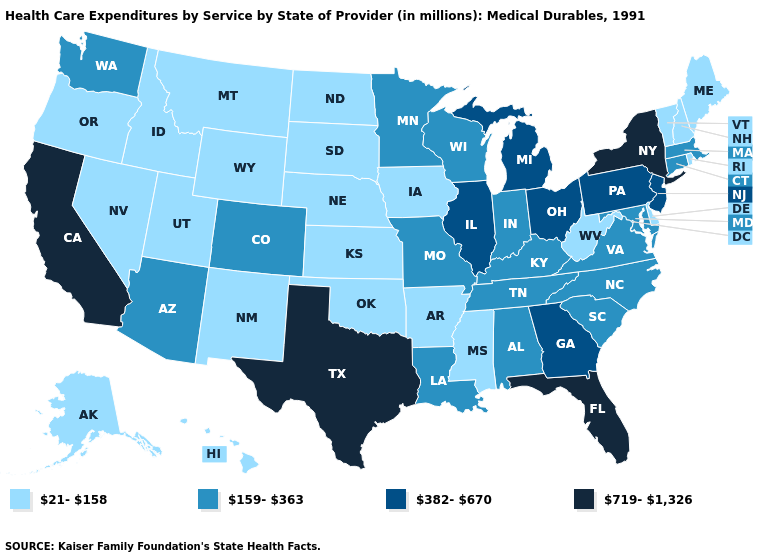What is the value of Alaska?
Write a very short answer. 21-158. Which states have the highest value in the USA?
Quick response, please. California, Florida, New York, Texas. Name the states that have a value in the range 159-363?
Keep it brief. Alabama, Arizona, Colorado, Connecticut, Indiana, Kentucky, Louisiana, Maryland, Massachusetts, Minnesota, Missouri, North Carolina, South Carolina, Tennessee, Virginia, Washington, Wisconsin. What is the value of South Carolina?
Be succinct. 159-363. What is the value of Louisiana?
Give a very brief answer. 159-363. Which states have the lowest value in the USA?
Quick response, please. Alaska, Arkansas, Delaware, Hawaii, Idaho, Iowa, Kansas, Maine, Mississippi, Montana, Nebraska, Nevada, New Hampshire, New Mexico, North Dakota, Oklahoma, Oregon, Rhode Island, South Dakota, Utah, Vermont, West Virginia, Wyoming. Does the map have missing data?
Write a very short answer. No. What is the value of Rhode Island?
Give a very brief answer. 21-158. What is the value of Kansas?
Give a very brief answer. 21-158. Among the states that border West Virginia , does Pennsylvania have the lowest value?
Write a very short answer. No. Among the states that border Texas , does Oklahoma have the highest value?
Keep it brief. No. Does Indiana have a higher value than Connecticut?
Answer briefly. No. What is the highest value in the USA?
Quick response, please. 719-1,326. What is the lowest value in the MidWest?
Concise answer only. 21-158. What is the value of California?
Concise answer only. 719-1,326. 